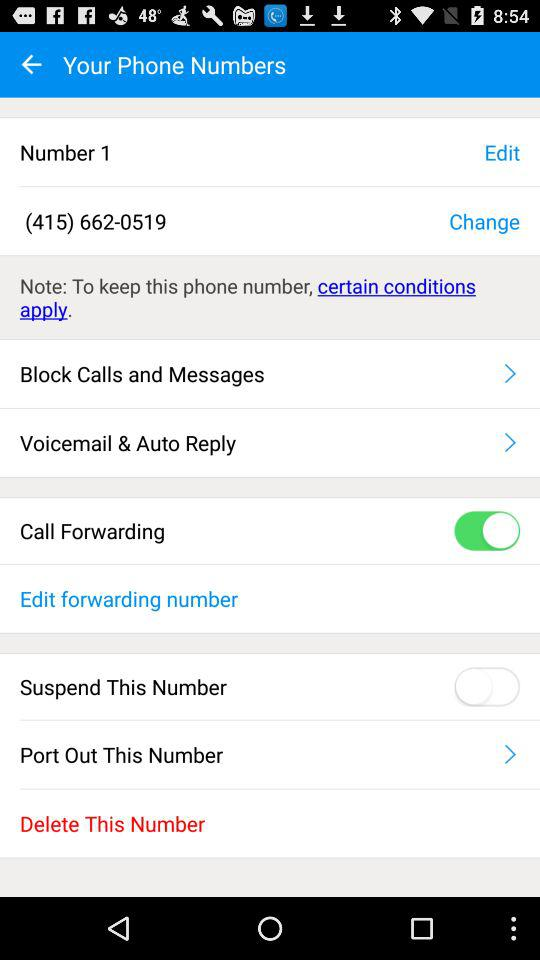What is the phone number? The phone number is (415) 662-0519. 